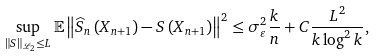<formula> <loc_0><loc_0><loc_500><loc_500>\sup _ { \left \| S \right \| _ { \mathcal { L } _ { 2 } } \leq L } \mathbb { E } \left \| \widehat { S } _ { n } \left ( X _ { n + 1 } \right ) - S \left ( X _ { n + 1 } \right ) \right \| ^ { 2 } \leq \sigma _ { \varepsilon } ^ { 2 } \frac { k } { n } + C \frac { L ^ { 2 } } { k \log ^ { 2 } k } ,</formula> 